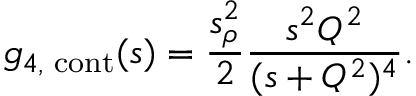Convert formula to latex. <formula><loc_0><loc_0><loc_500><loc_500>g _ { 4 , c o n t } ( s ) = \frac { s _ { \rho } ^ { 2 } } { 2 } \frac { s ^ { 2 } Q ^ { 2 } } { ( s + Q ^ { 2 } ) ^ { 4 } } .</formula> 